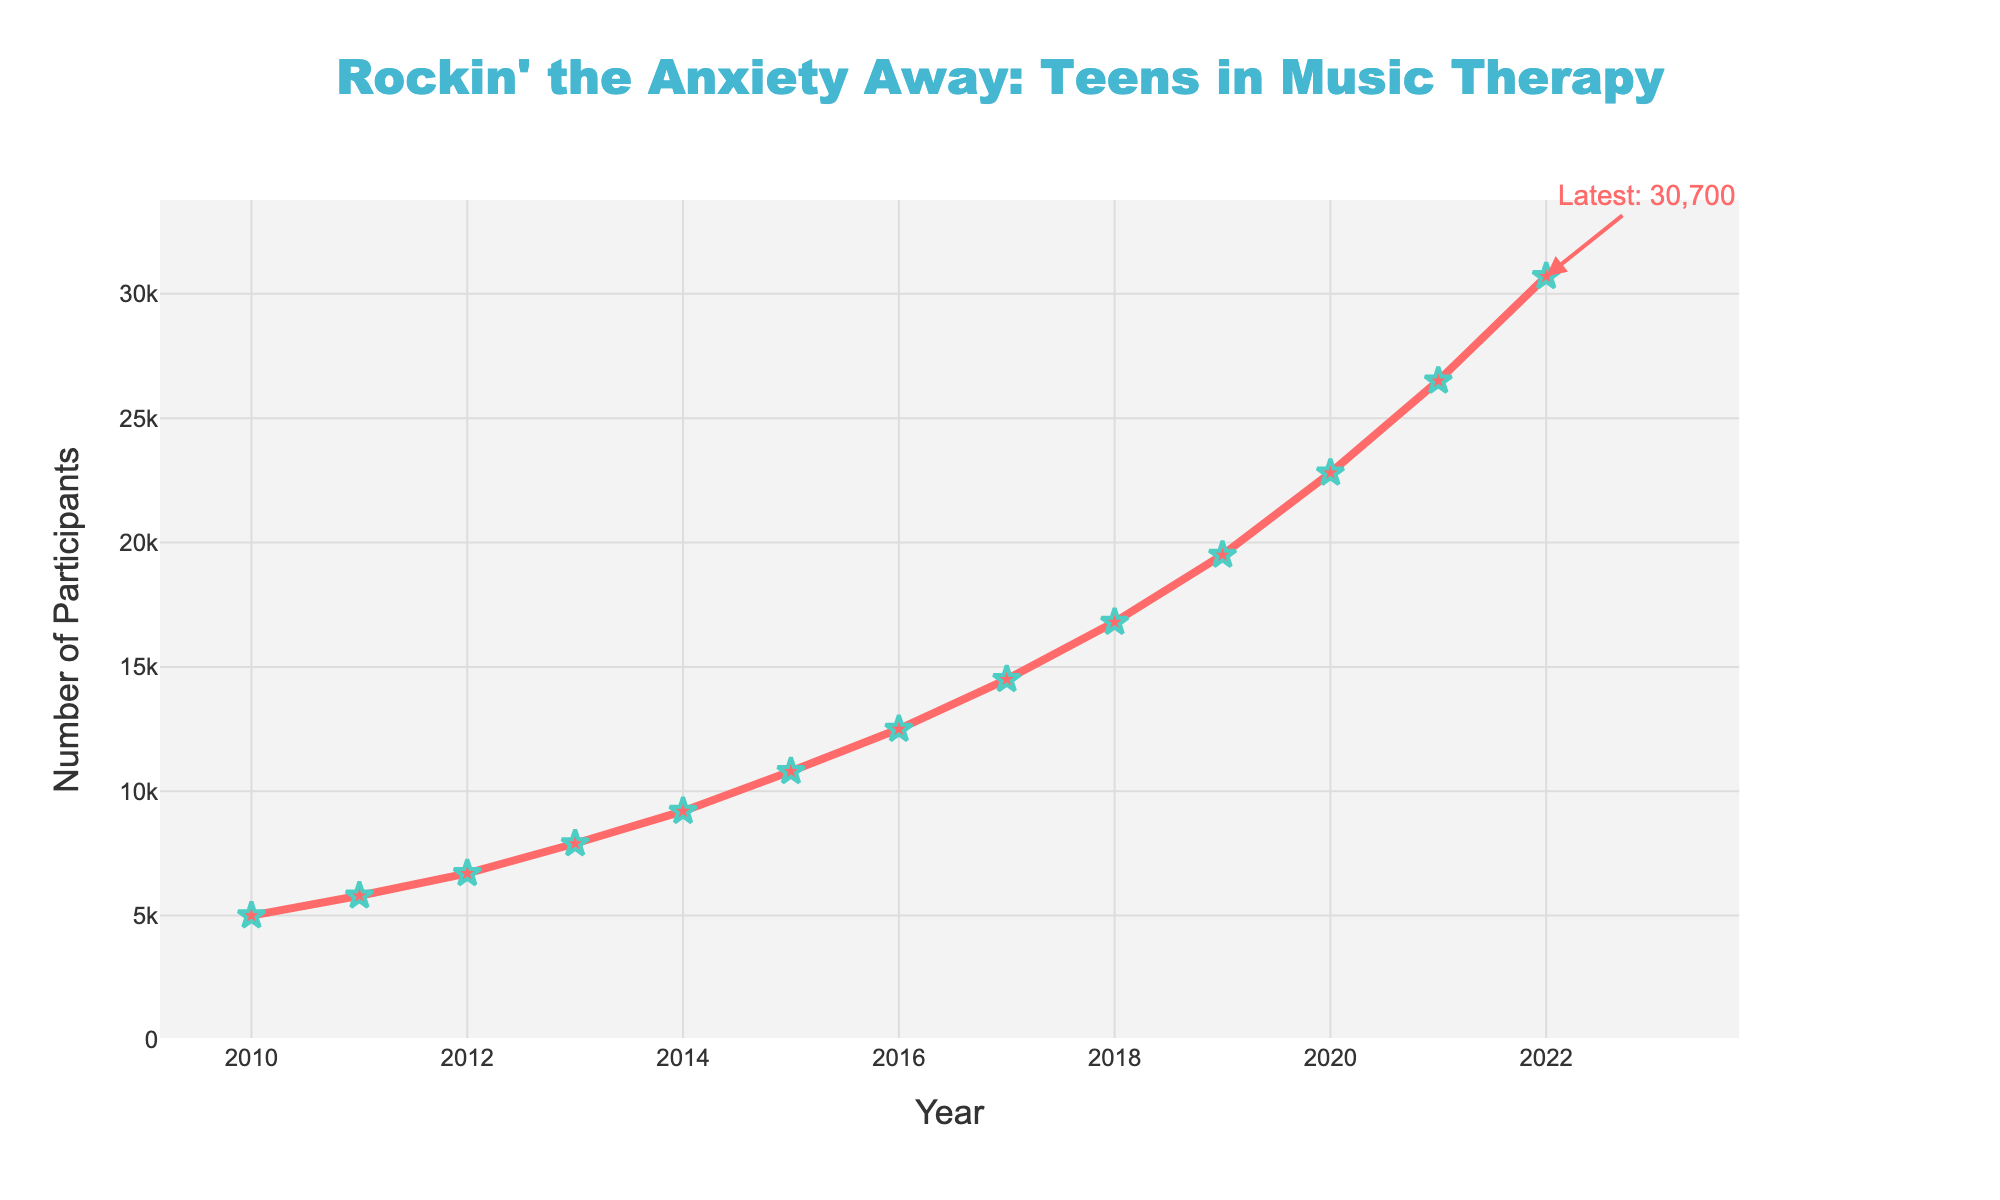How has the number of participants changed from 2010 to 2022? The figure shows the number of participants in 2010 as 5000 and in 2022 as 30700. The change is calculated by subtracting the 2010 value from the 2022 value (30700 - 5000).
Answer: 25700 What was the year with the highest increase in participants? By observing the steepness of the lines between each year, the steepest increase occurs between 2021 and 2022. The number jumps from 26500 to 30700, indicating the largest rise.
Answer: 2021 to 2022 Is the growth in the number of participants steady over the years? The line chart displays a steadily increasing trend without any decreases or significant plateaus, indicating consistent growth.
Answer: Yes What's the percentage increase in participants from 2010 to 2022? Calculate the percentage increase using the formula: ((New Value - Old Value) / Old Value) * 100. Here, ((30700 - 5000) / 5000) * 100.
Answer: 514% Compare the growth in participants between the first half (2010-2016) and the second half (2017-2022) of the data. Calculate the differences for both periods: 2010-2016 (12500 - 5000 = 7500) and 2017-2022 (30700 - 14500 = 16200). The second half shows a much higher increase.
Answer: Second half had greater growth Is there any year where the number of participants exceeds 20,000? From the chart, the year 2020 shows participants exceeding 20,000, marking the first time this threshold is crossed.
Answer: 2020 What is the average number of participants over the entire period? Sum all participants and divide by the number of years: (5000 + 5800 + 6700 + 7900 + 9200 + 10800 + 12500 + 14500 + 16800 + 19500 + 22800 + 26500 + 30700) / 13.
Answer: 14146.15 What was the participant count trend from 2010 to 2014? From 2010 (5000) to 2014 (9200), the participant count shows a steady increase. Every year, the number increases consistently.
Answer: Steady increase Between which consecutive years is the smallest increase in the number of participants? The smallest increase occurs between 2011 (5800) and 2012 (6700). The increase here is 900, which is the smallest increase evident in the chart.
Answer: 2011 to 2012 Considering the whole period, was there ever a year when participants decreased from the previous year? The chart shows no points where the line dips downward, indicating no years where participants decreased from the previous year.
Answer: No 